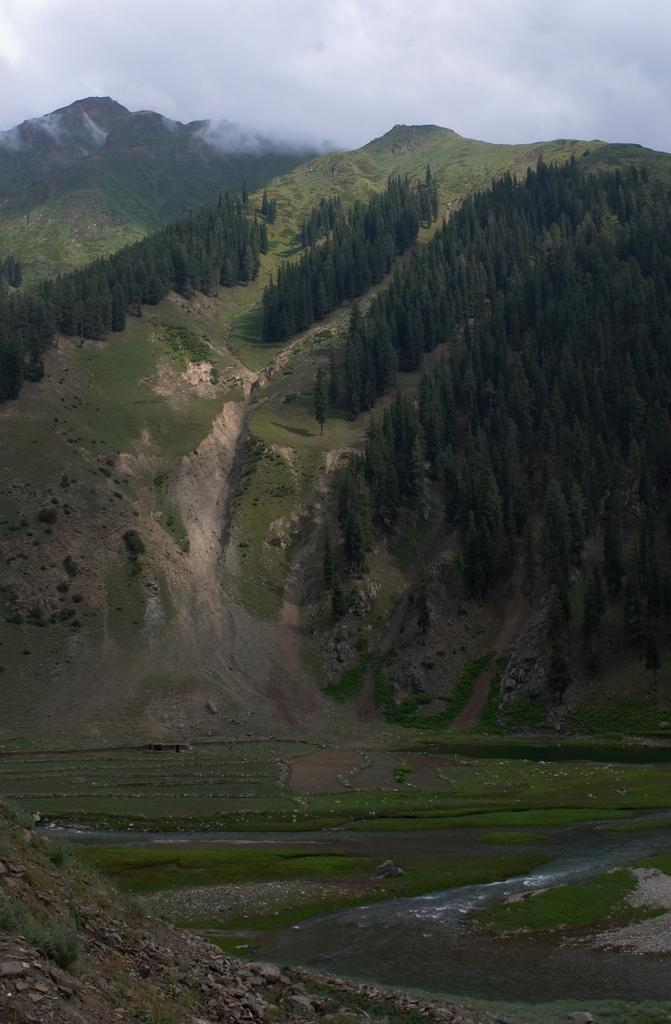What type of natural environment is depicted in the image? The image features water, grass, plants, trees, and hills, which are all elements of a natural environment. Can you describe the vegetation in the image? The image includes grass, plants, and trees. What is visible in the background of the image? The sky is visible in the image. What type of iron is being used for digestion in the image? There is no iron or any reference to digestion present in the image. 